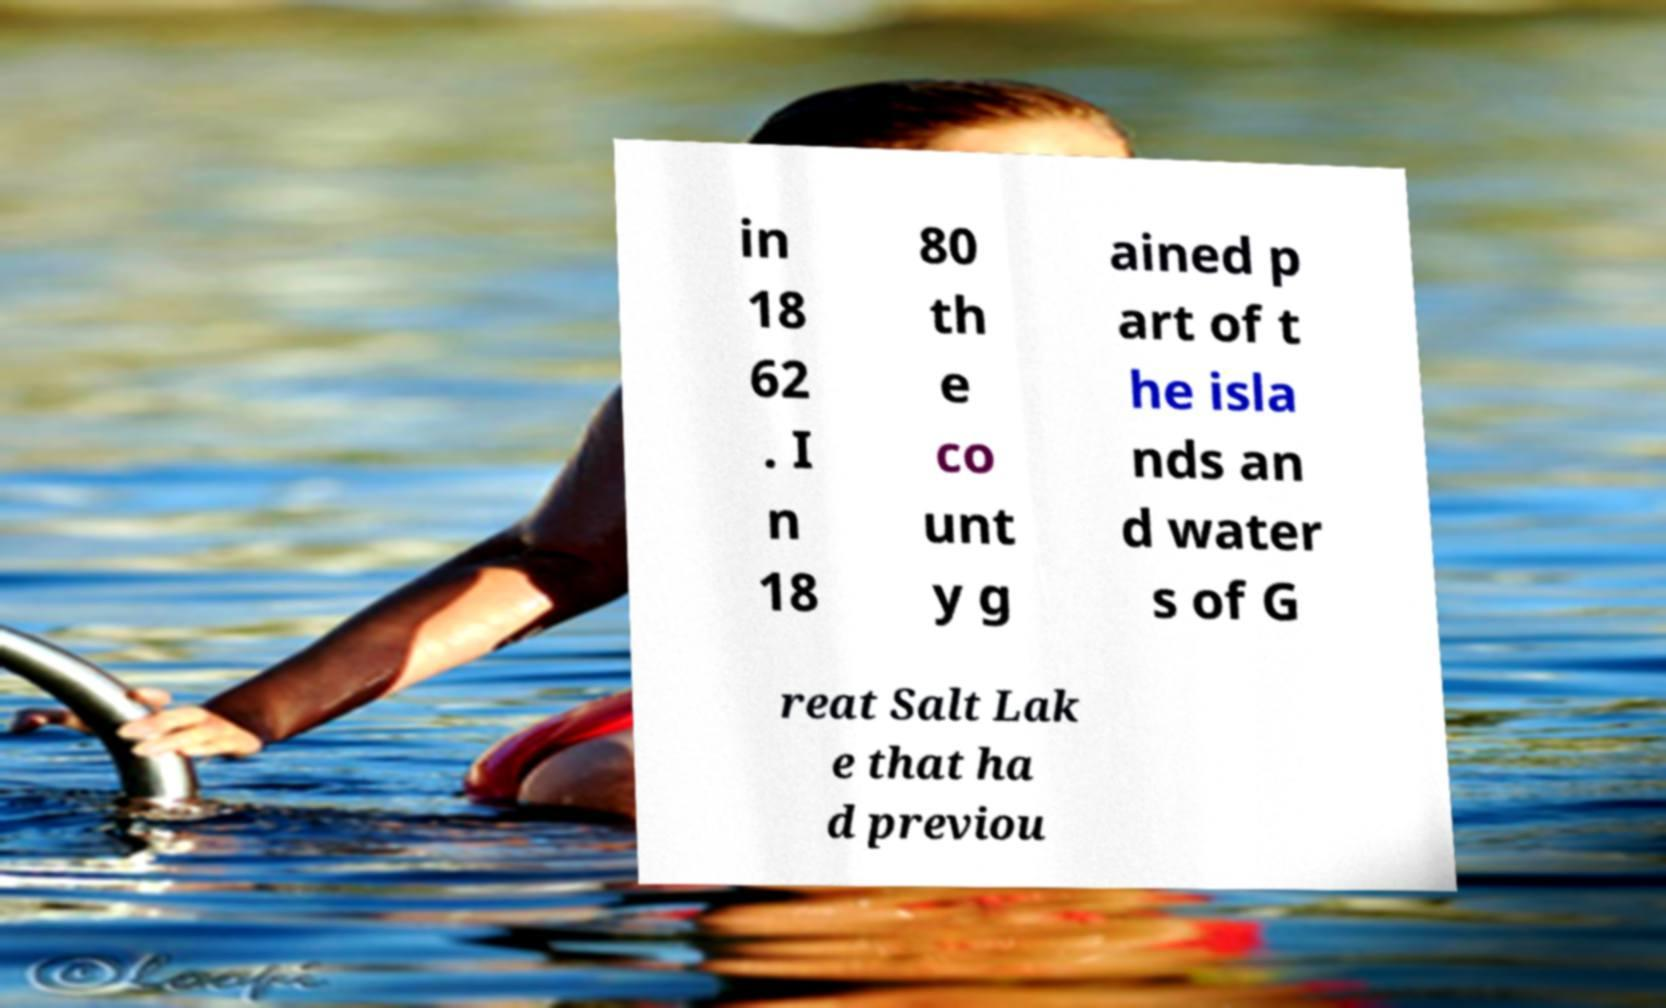Please read and relay the text visible in this image. What does it say? in 18 62 . I n 18 80 th e co unt y g ained p art of t he isla nds an d water s of G reat Salt Lak e that ha d previou 